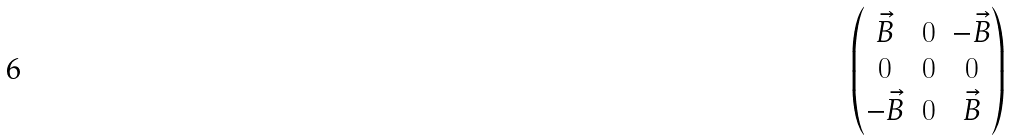Convert formula to latex. <formula><loc_0><loc_0><loc_500><loc_500>\begin{pmatrix} \vec { B } & 0 & - \vec { B } \\ 0 & 0 & 0 \\ - \vec { B } & 0 & \vec { B } \end{pmatrix}</formula> 